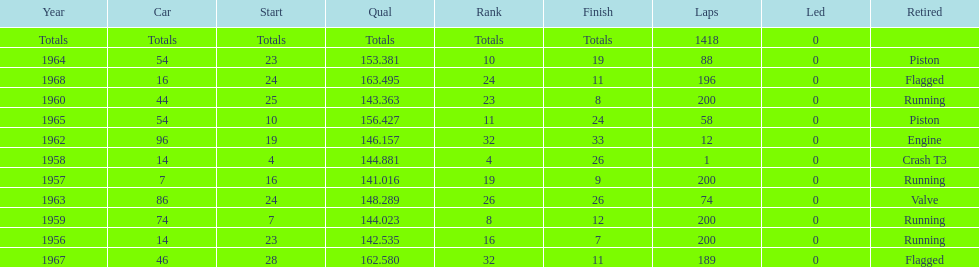Which year is the last qual on the chart 1968. 